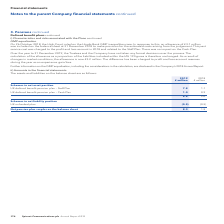According to Spirent Communications Plc's financial document, What was the net pension plan surplus on the balance sheet in 2019? According to the financial document, 8.3 (in millions). The relevant text states: "Net pension plan surplus on the balance sheet 8.3 1.5..." Also, What are the schemes comprising the assets and liabilities on the balance sheet in the table? The document shows two values: Schemes in net asset position and Schemes in net liability position. From the document: "Schemes in net asset position Schemes in net liability position..." Also, What are the plans under Schemes in net asset position? The document shows two values: UK defined benefit pension plan – Staff Plan and UK defined benefit pension plan – Cash Plan. From the document: "UK defined benefit pension plan – Staff Plan 7.8 1.1 UK defined benefit pension plan – Cash Plan 1.0 0.9..." Additionally, In which year was the amount of UK defined benefit pension plan – Cash Plan larger? According to the financial document, 2019. The relevant text states: "174 Spirent Communications plc Annual Report 2019..." Also, can you calculate: What was the change in the net pension plan surplus on the balance sheet? Based on the calculation: 8.3-1.5, the result is 6.8 (in millions). This is based on the information: "Net pension plan surplus on the balance sheet 8.3 1.5 Net pension plan surplus on the balance sheet 8.3 1.5..." The key data points involved are: 1.5, 8.3. Also, can you calculate: What was the percentage change in the net pension plan surplus on the balance sheet? To answer this question, I need to perform calculations using the financial data. The calculation is: (8.3-1.5)/1.5, which equals 453.33 (percentage). This is based on the information: "Net pension plan surplus on the balance sheet 8.3 1.5 Net pension plan surplus on the balance sheet 8.3 1.5..." The key data points involved are: 1.5, 8.3. 